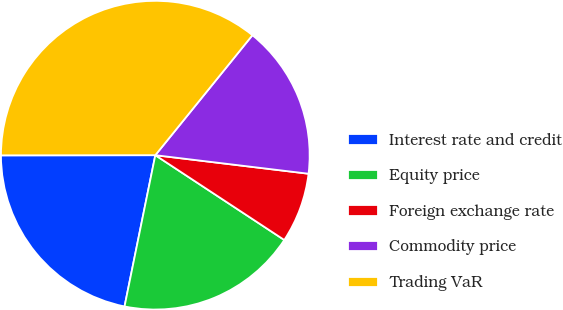<chart> <loc_0><loc_0><loc_500><loc_500><pie_chart><fcel>Interest rate and credit<fcel>Equity price<fcel>Foreign exchange rate<fcel>Commodity price<fcel>Trading VaR<nl><fcel>21.79%<fcel>18.94%<fcel>7.34%<fcel>16.09%<fcel>35.85%<nl></chart> 